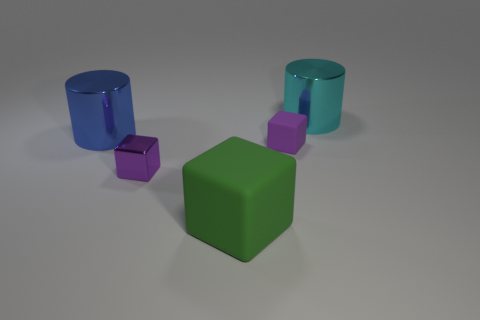Add 1 large yellow shiny things. How many objects exist? 6 Subtract all cylinders. How many objects are left? 3 Add 5 purple objects. How many purple objects are left? 7 Add 1 metallic balls. How many metallic balls exist? 1 Subtract 0 cyan blocks. How many objects are left? 5 Subtract all tiny brown things. Subtract all blue shiny cylinders. How many objects are left? 4 